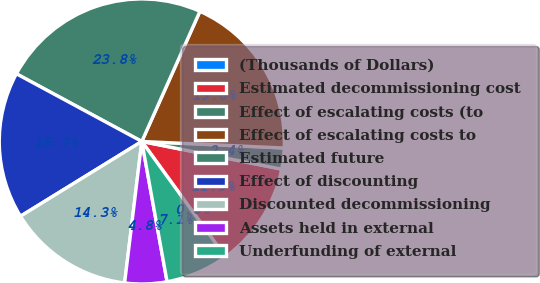<chart> <loc_0><loc_0><loc_500><loc_500><pie_chart><fcel>(Thousands of Dollars)<fcel>Estimated decommissioning cost<fcel>Effect of escalating costs (to<fcel>Effect of escalating costs to<fcel>Estimated future<fcel>Effect of discounting<fcel>Discounted decommissioning<fcel>Assets held in external<fcel>Underfunding of external<nl><fcel>0.0%<fcel>11.9%<fcel>2.38%<fcel>19.04%<fcel>23.8%<fcel>16.66%<fcel>14.28%<fcel>4.76%<fcel>7.14%<nl></chart> 